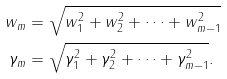Convert formula to latex. <formula><loc_0><loc_0><loc_500><loc_500>w _ { m } & = \sqrt { w _ { 1 } ^ { 2 } + w _ { 2 } ^ { 2 } + \dots + w _ { m - 1 } ^ { 2 } } \\ \gamma _ { m } & = \sqrt { \gamma _ { 1 } ^ { 2 } + \gamma _ { 2 } ^ { 2 } + \dots + \gamma _ { m - 1 } ^ { 2 } } .</formula> 